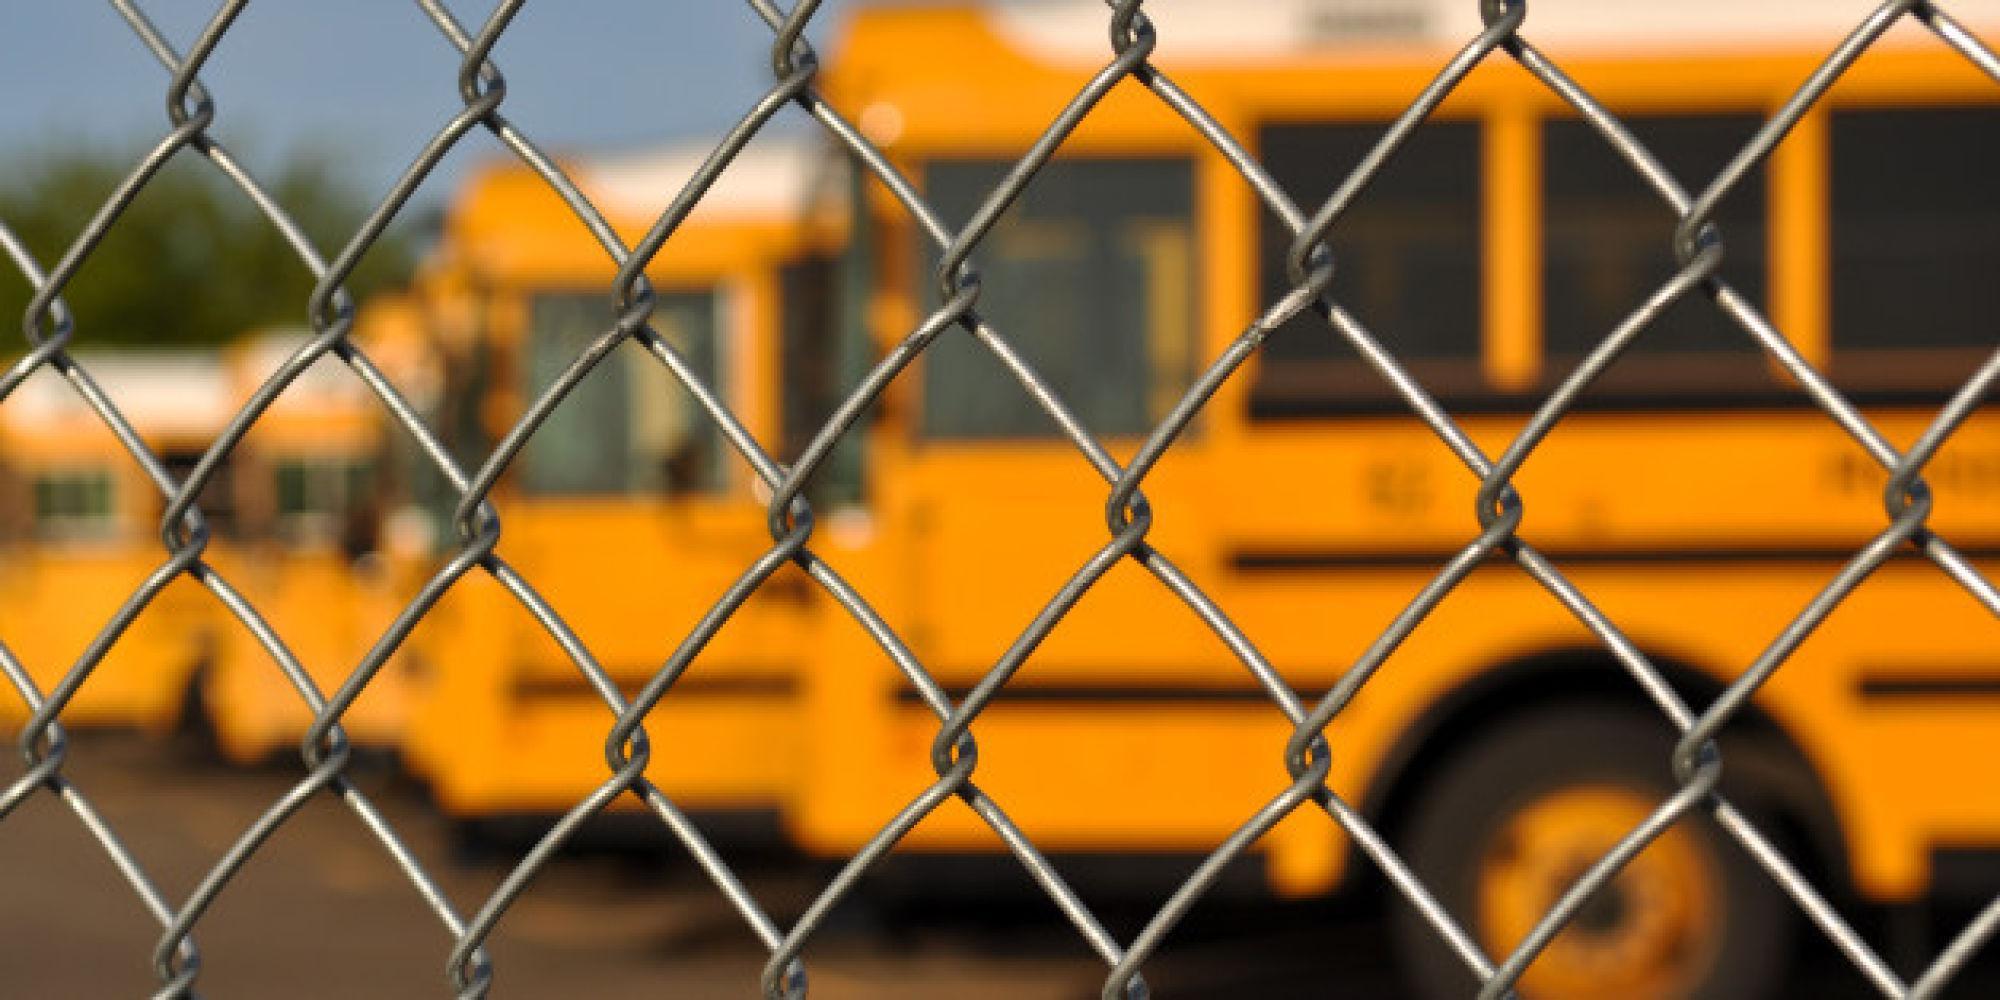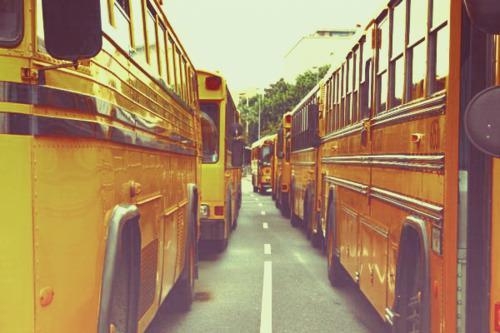The first image is the image on the left, the second image is the image on the right. For the images shown, is this caption "The buses on the right are parked in two columns that are close together." true? Answer yes or no. Yes. The first image is the image on the left, the second image is the image on the right. For the images shown, is this caption "One image shows parked yellow school buses viewed through chain link fence, and the other image shows a 'diminishing perspective' view of the length of at least one bus." true? Answer yes or no. Yes. 